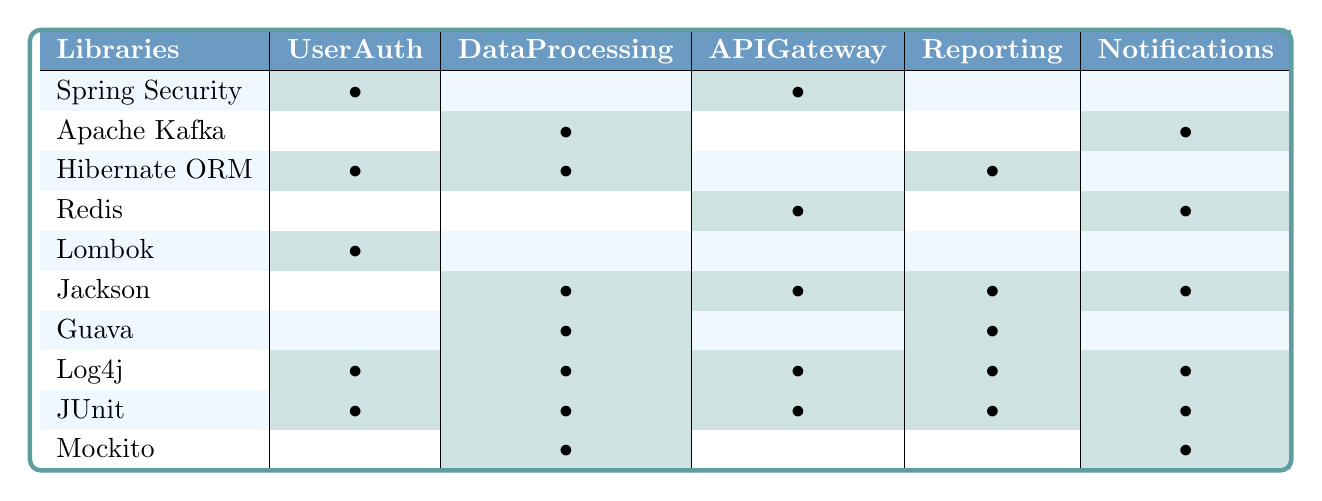What libraries are used in the UserAuth module? By looking at the UserAuth column, the libraries listed are Spring Security, Hibernate ORM, Lombok, Log4j, and JUnit.
Answer: Spring Security, Hibernate ORM, Lombok, Log4j, JUnit Which module has the most dependencies? We can count the number of libraries associated with each module. DataProcessing has 7 dependencies, which is the highest.
Answer: DataProcessing Is Mockito used in the APIGateway module? Checking the APIGateway column, there is no bullet indicating the presence of Mockito.
Answer: No How many modules utilize Log4j? By counting the bullets in the Log4j row, we find that all 5 modules use Log4j.
Answer: 5 Which libraries are shared between the UserAuth and Reporting modules? We look at the libraries used in both modules. The only shared library is Hibernate ORM since both have a bullet in the same row.
Answer: Hibernate ORM What is the total number of unique libraries used across all modules? By listing all the libraries mentioned, we find 10 unique libraries.
Answer: 10 Does the Notifications module use any library that is also used in the DataProcessing module? Examining both modules, we find that Jackson, Log4j, and JUnit are present in both.
Answer: Yes Which module has the least dependencies? Counting the libraries for each module, UserAuth and Notifications each have 5 dependencies, but UserAuth appears first in the list.
Answer: UserAuth How many modules do not use Redis? Checking the Redis row, we see that UserAuth and DataProcessing do not include it. Hence, 3 modules do not use Redis.
Answer: 3 Is there a library that is common to all modules? Reviewing the table, JUnit appears in all modules, as indicated by a bullet in each row.
Answer: Yes, JUnit 